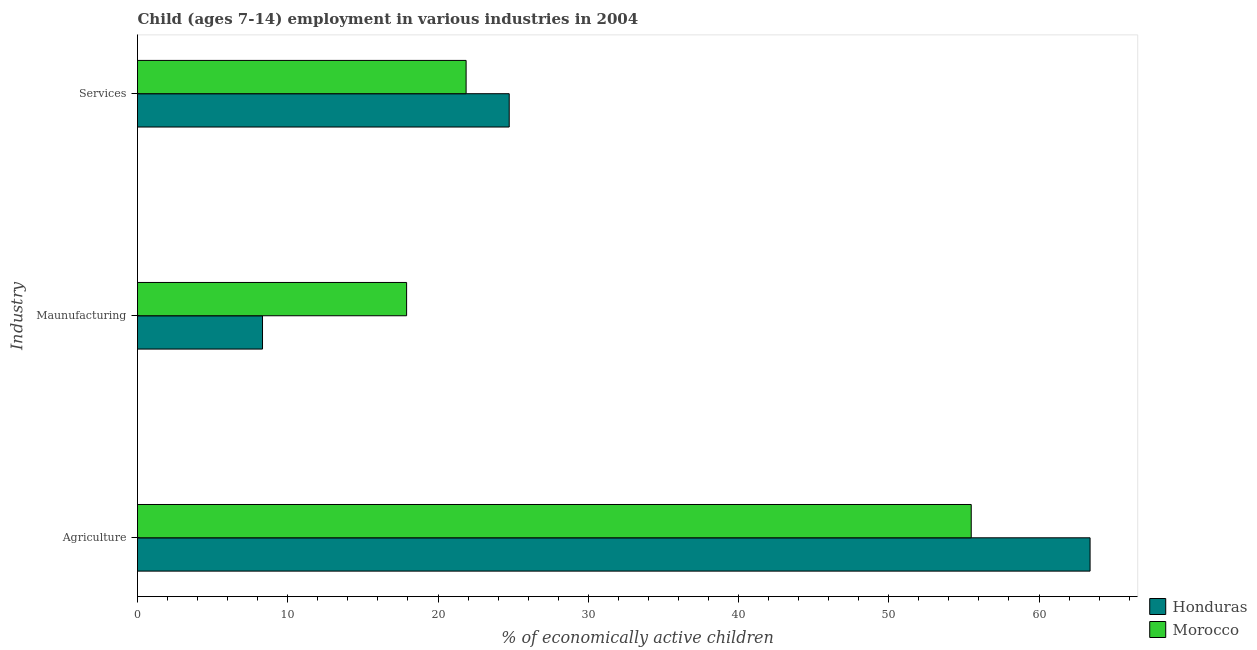How many different coloured bars are there?
Your answer should be very brief. 2. Are the number of bars on each tick of the Y-axis equal?
Ensure brevity in your answer.  Yes. How many bars are there on the 1st tick from the top?
Give a very brief answer. 2. How many bars are there on the 2nd tick from the bottom?
Offer a terse response. 2. What is the label of the 2nd group of bars from the top?
Your answer should be compact. Maunufacturing. What is the percentage of economically active children in services in Morocco?
Ensure brevity in your answer.  21.87. Across all countries, what is the maximum percentage of economically active children in services?
Give a very brief answer. 24.74. Across all countries, what is the minimum percentage of economically active children in manufacturing?
Your answer should be compact. 8.32. In which country was the percentage of economically active children in services maximum?
Provide a short and direct response. Honduras. In which country was the percentage of economically active children in services minimum?
Make the answer very short. Morocco. What is the total percentage of economically active children in agriculture in the graph?
Give a very brief answer. 118.89. What is the difference between the percentage of economically active children in services in Morocco and that in Honduras?
Offer a terse response. -2.87. What is the difference between the percentage of economically active children in agriculture in Morocco and the percentage of economically active children in manufacturing in Honduras?
Your response must be concise. 47.17. What is the average percentage of economically active children in manufacturing per country?
Provide a short and direct response. 13.12. What is the difference between the percentage of economically active children in manufacturing and percentage of economically active children in agriculture in Honduras?
Offer a very short reply. -55.08. In how many countries, is the percentage of economically active children in manufacturing greater than 34 %?
Keep it short and to the point. 0. What is the ratio of the percentage of economically active children in services in Morocco to that in Honduras?
Provide a short and direct response. 0.88. What is the difference between the highest and the second highest percentage of economically active children in manufacturing?
Offer a very short reply. 9.59. What is the difference between the highest and the lowest percentage of economically active children in manufacturing?
Make the answer very short. 9.59. In how many countries, is the percentage of economically active children in agriculture greater than the average percentage of economically active children in agriculture taken over all countries?
Provide a succinct answer. 1. What does the 2nd bar from the top in Maunufacturing represents?
Ensure brevity in your answer.  Honduras. What does the 1st bar from the bottom in Maunufacturing represents?
Ensure brevity in your answer.  Honduras. Are all the bars in the graph horizontal?
Provide a succinct answer. Yes. How many countries are there in the graph?
Your answer should be compact. 2. What is the difference between two consecutive major ticks on the X-axis?
Ensure brevity in your answer.  10. Where does the legend appear in the graph?
Provide a succinct answer. Bottom right. How many legend labels are there?
Offer a terse response. 2. How are the legend labels stacked?
Keep it short and to the point. Vertical. What is the title of the graph?
Provide a succinct answer. Child (ages 7-14) employment in various industries in 2004. Does "Caribbean small states" appear as one of the legend labels in the graph?
Your answer should be compact. No. What is the label or title of the X-axis?
Give a very brief answer. % of economically active children. What is the label or title of the Y-axis?
Offer a very short reply. Industry. What is the % of economically active children of Honduras in Agriculture?
Make the answer very short. 63.4. What is the % of economically active children of Morocco in Agriculture?
Keep it short and to the point. 55.49. What is the % of economically active children in Honduras in Maunufacturing?
Your answer should be very brief. 8.32. What is the % of economically active children in Morocco in Maunufacturing?
Ensure brevity in your answer.  17.91. What is the % of economically active children of Honduras in Services?
Your answer should be compact. 24.74. What is the % of economically active children in Morocco in Services?
Keep it short and to the point. 21.87. Across all Industry, what is the maximum % of economically active children in Honduras?
Your response must be concise. 63.4. Across all Industry, what is the maximum % of economically active children of Morocco?
Give a very brief answer. 55.49. Across all Industry, what is the minimum % of economically active children in Honduras?
Give a very brief answer. 8.32. Across all Industry, what is the minimum % of economically active children in Morocco?
Make the answer very short. 17.91. What is the total % of economically active children in Honduras in the graph?
Ensure brevity in your answer.  96.46. What is the total % of economically active children of Morocco in the graph?
Offer a very short reply. 95.27. What is the difference between the % of economically active children of Honduras in Agriculture and that in Maunufacturing?
Your response must be concise. 55.08. What is the difference between the % of economically active children of Morocco in Agriculture and that in Maunufacturing?
Ensure brevity in your answer.  37.58. What is the difference between the % of economically active children in Honduras in Agriculture and that in Services?
Offer a terse response. 38.66. What is the difference between the % of economically active children of Morocco in Agriculture and that in Services?
Your answer should be very brief. 33.62. What is the difference between the % of economically active children of Honduras in Maunufacturing and that in Services?
Ensure brevity in your answer.  -16.42. What is the difference between the % of economically active children in Morocco in Maunufacturing and that in Services?
Keep it short and to the point. -3.96. What is the difference between the % of economically active children of Honduras in Agriculture and the % of economically active children of Morocco in Maunufacturing?
Provide a succinct answer. 45.49. What is the difference between the % of economically active children in Honduras in Agriculture and the % of economically active children in Morocco in Services?
Offer a very short reply. 41.53. What is the difference between the % of economically active children of Honduras in Maunufacturing and the % of economically active children of Morocco in Services?
Offer a terse response. -13.55. What is the average % of economically active children in Honduras per Industry?
Give a very brief answer. 32.15. What is the average % of economically active children in Morocco per Industry?
Offer a terse response. 31.76. What is the difference between the % of economically active children of Honduras and % of economically active children of Morocco in Agriculture?
Your answer should be very brief. 7.91. What is the difference between the % of economically active children of Honduras and % of economically active children of Morocco in Maunufacturing?
Offer a terse response. -9.59. What is the difference between the % of economically active children of Honduras and % of economically active children of Morocco in Services?
Provide a short and direct response. 2.87. What is the ratio of the % of economically active children in Honduras in Agriculture to that in Maunufacturing?
Provide a succinct answer. 7.62. What is the ratio of the % of economically active children in Morocco in Agriculture to that in Maunufacturing?
Your answer should be very brief. 3.1. What is the ratio of the % of economically active children of Honduras in Agriculture to that in Services?
Ensure brevity in your answer.  2.56. What is the ratio of the % of economically active children in Morocco in Agriculture to that in Services?
Give a very brief answer. 2.54. What is the ratio of the % of economically active children in Honduras in Maunufacturing to that in Services?
Make the answer very short. 0.34. What is the ratio of the % of economically active children in Morocco in Maunufacturing to that in Services?
Make the answer very short. 0.82. What is the difference between the highest and the second highest % of economically active children of Honduras?
Ensure brevity in your answer.  38.66. What is the difference between the highest and the second highest % of economically active children of Morocco?
Keep it short and to the point. 33.62. What is the difference between the highest and the lowest % of economically active children in Honduras?
Make the answer very short. 55.08. What is the difference between the highest and the lowest % of economically active children in Morocco?
Make the answer very short. 37.58. 